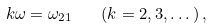Convert formula to latex. <formula><loc_0><loc_0><loc_500><loc_500>k \omega = \omega _ { 2 1 } \quad ( k = 2 , 3 , \dots ) \, ,</formula> 